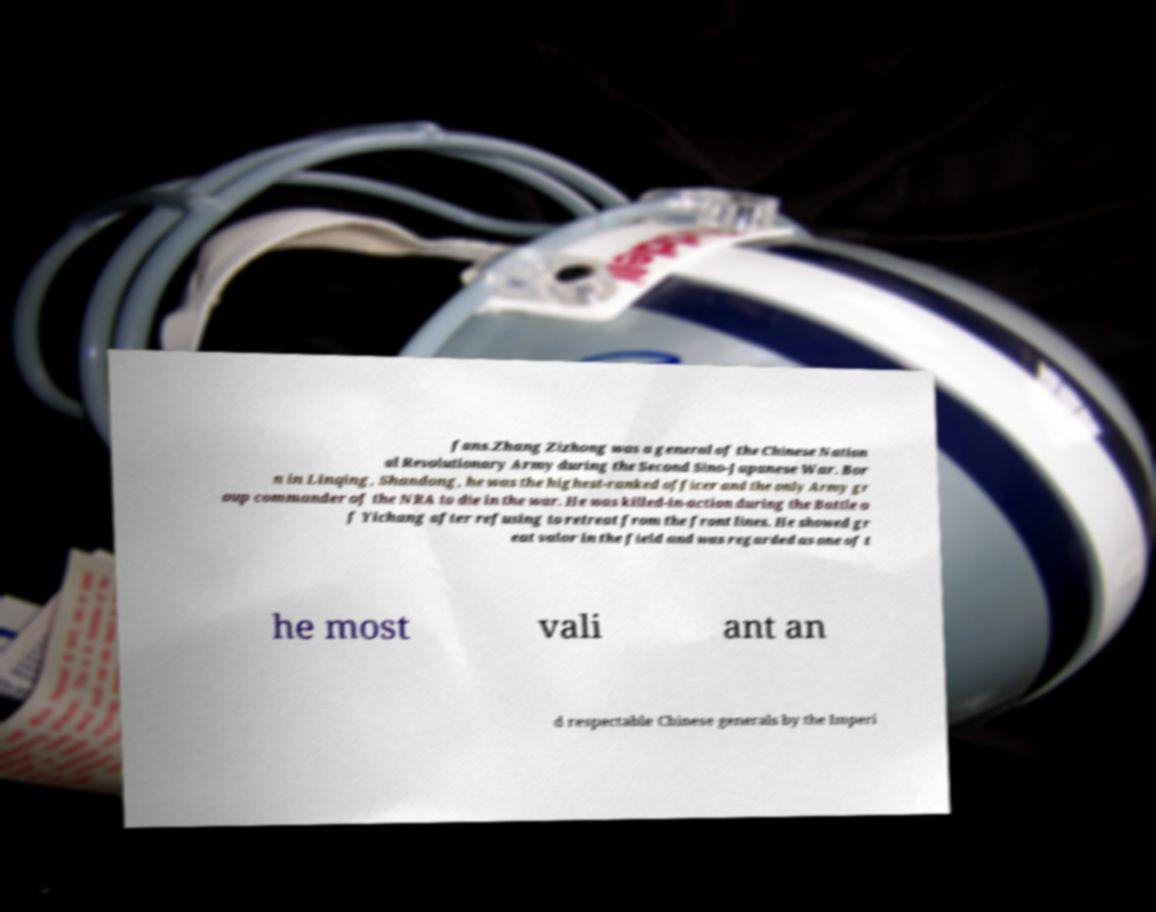What messages or text are displayed in this image? I need them in a readable, typed format. fans.Zhang Zizhong was a general of the Chinese Nation al Revolutionary Army during the Second Sino-Japanese War. Bor n in Linqing, Shandong, he was the highest-ranked officer and the only Army gr oup commander of the NRA to die in the war. He was killed-in-action during the Battle o f Yichang after refusing to retreat from the front lines. He showed gr eat valor in the field and was regarded as one of t he most vali ant an d respectable Chinese generals by the Imperi 